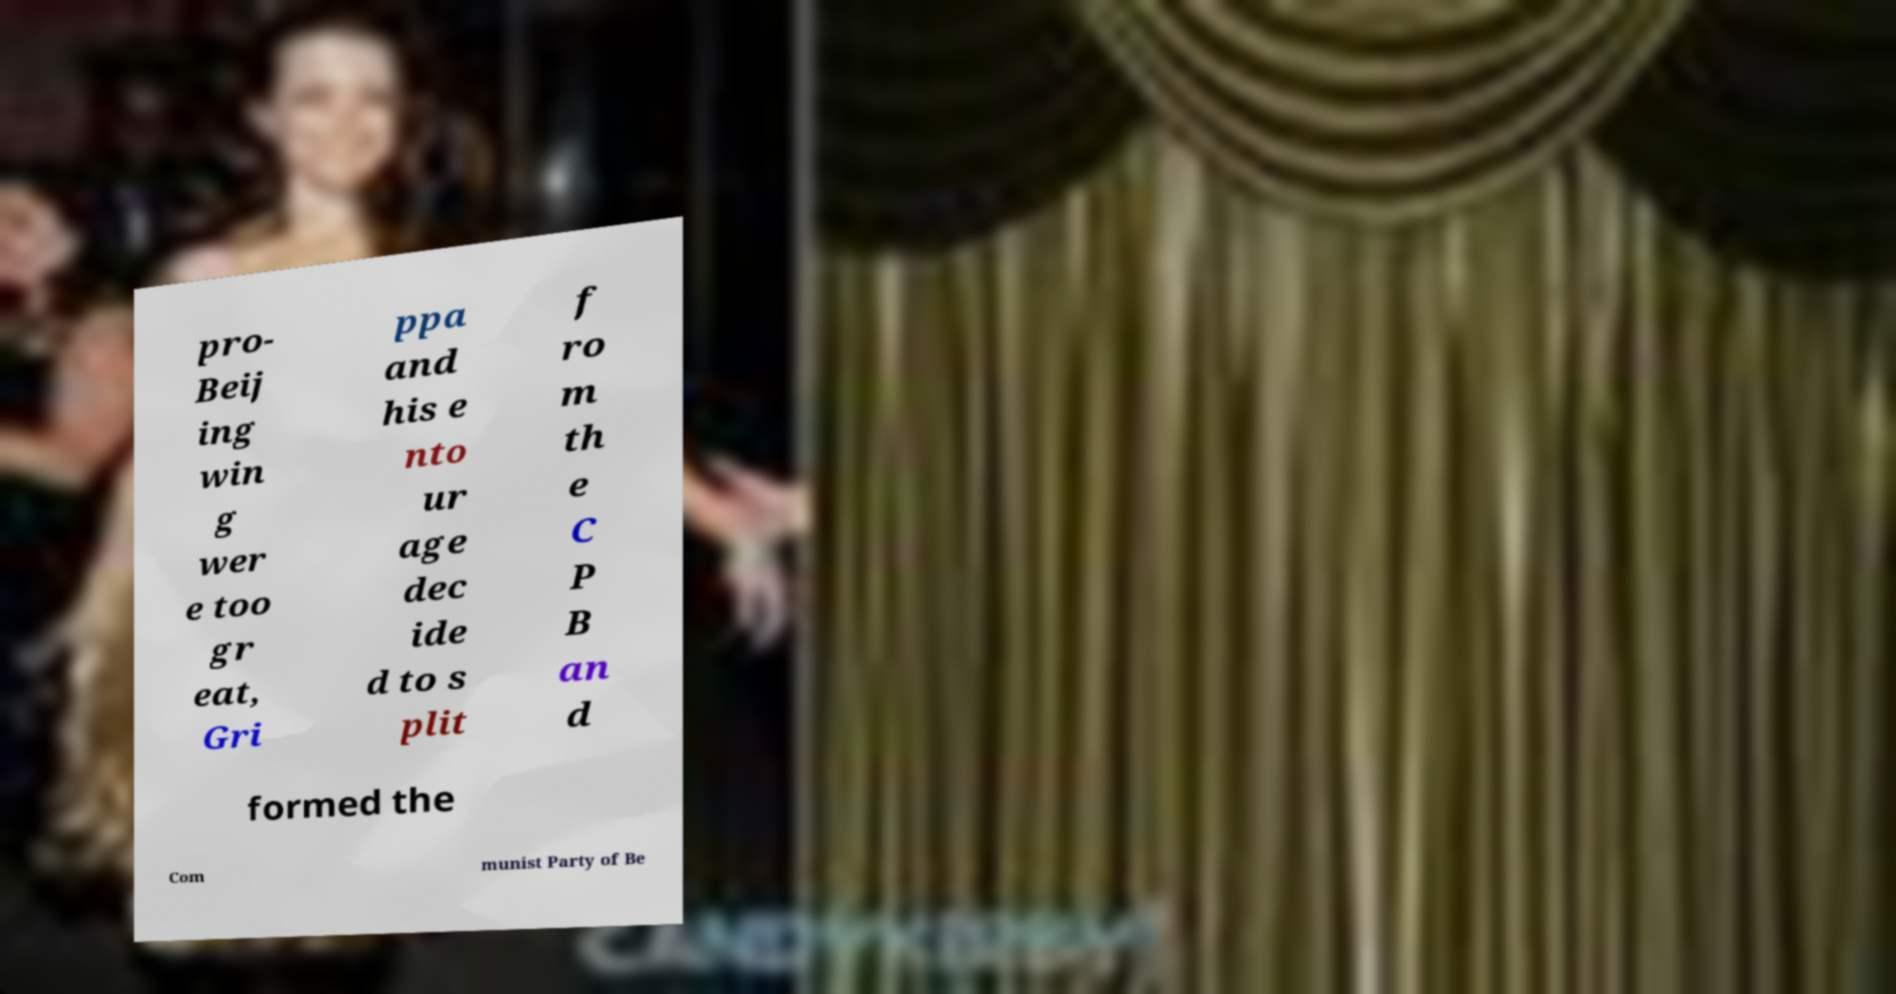Please read and relay the text visible in this image. What does it say? pro- Beij ing win g wer e too gr eat, Gri ppa and his e nto ur age dec ide d to s plit f ro m th e C P B an d formed the Com munist Party of Be 